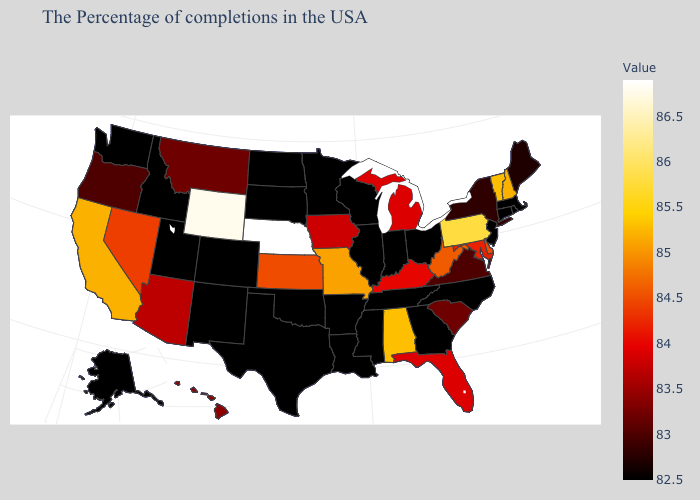Does Louisiana have the lowest value in the USA?
Concise answer only. Yes. Which states hav the highest value in the MidWest?
Write a very short answer. Nebraska. 